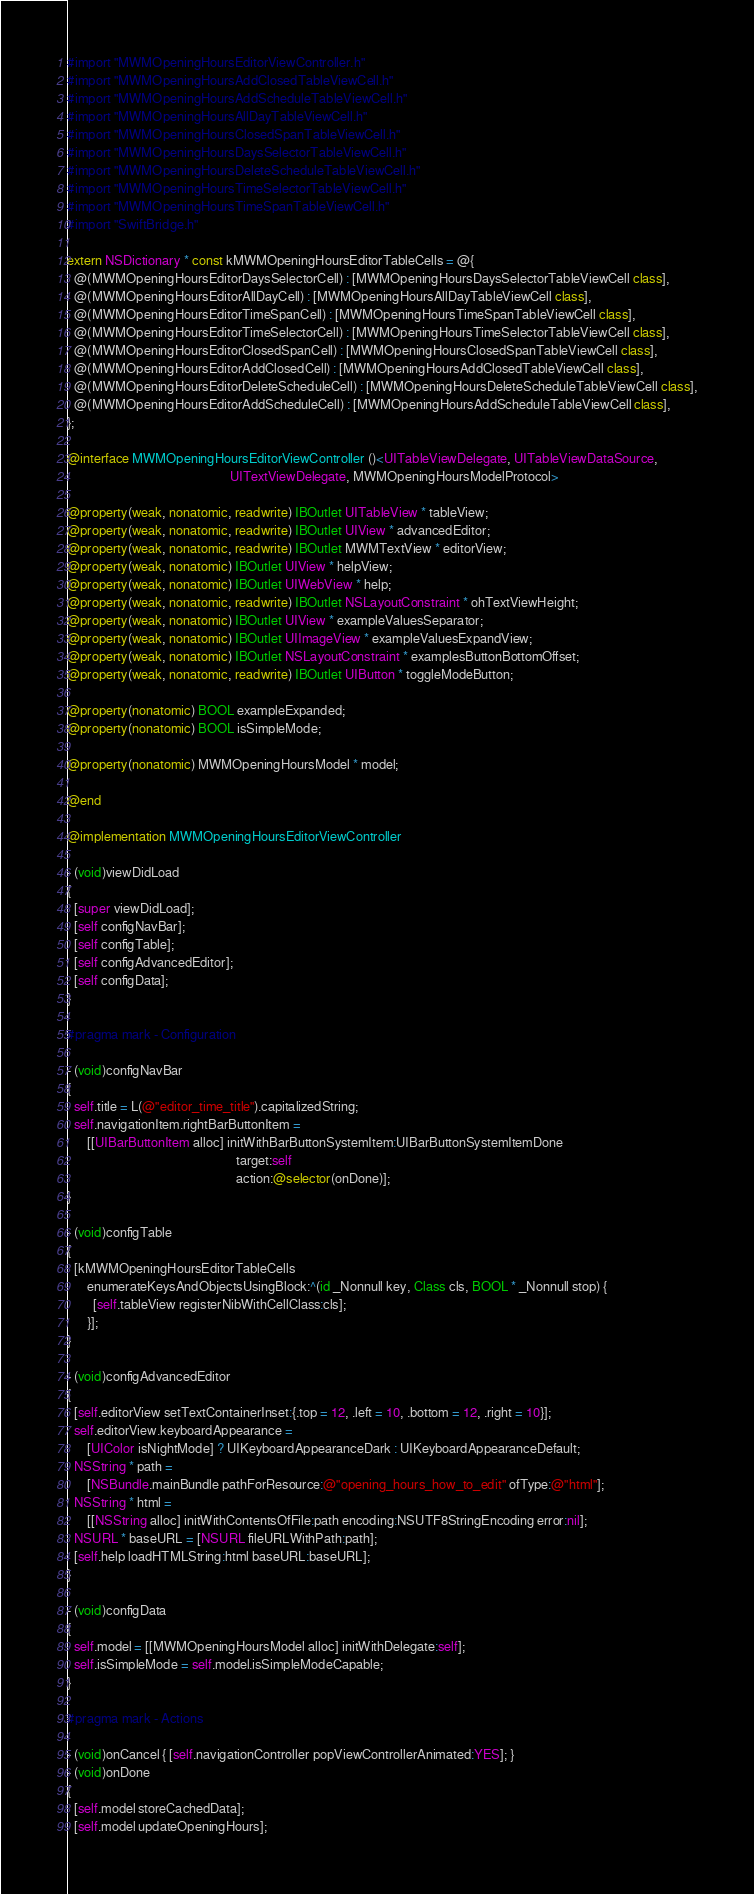Convert code to text. <code><loc_0><loc_0><loc_500><loc_500><_ObjectiveC_>#import "MWMOpeningHoursEditorViewController.h"
#import "MWMOpeningHoursAddClosedTableViewCell.h"
#import "MWMOpeningHoursAddScheduleTableViewCell.h"
#import "MWMOpeningHoursAllDayTableViewCell.h"
#import "MWMOpeningHoursClosedSpanTableViewCell.h"
#import "MWMOpeningHoursDaysSelectorTableViewCell.h"
#import "MWMOpeningHoursDeleteScheduleTableViewCell.h"
#import "MWMOpeningHoursTimeSelectorTableViewCell.h"
#import "MWMOpeningHoursTimeSpanTableViewCell.h"
#import "SwiftBridge.h"

extern NSDictionary * const kMWMOpeningHoursEditorTableCells = @{
  @(MWMOpeningHoursEditorDaysSelectorCell) : [MWMOpeningHoursDaysSelectorTableViewCell class],
  @(MWMOpeningHoursEditorAllDayCell) : [MWMOpeningHoursAllDayTableViewCell class],
  @(MWMOpeningHoursEditorTimeSpanCell) : [MWMOpeningHoursTimeSpanTableViewCell class],
  @(MWMOpeningHoursEditorTimeSelectorCell) : [MWMOpeningHoursTimeSelectorTableViewCell class],
  @(MWMOpeningHoursEditorClosedSpanCell) : [MWMOpeningHoursClosedSpanTableViewCell class],
  @(MWMOpeningHoursEditorAddClosedCell) : [MWMOpeningHoursAddClosedTableViewCell class],
  @(MWMOpeningHoursEditorDeleteScheduleCell) : [MWMOpeningHoursDeleteScheduleTableViewCell class],
  @(MWMOpeningHoursEditorAddScheduleCell) : [MWMOpeningHoursAddScheduleTableViewCell class],
};

@interface MWMOpeningHoursEditorViewController ()<UITableViewDelegate, UITableViewDataSource,
                                                  UITextViewDelegate, MWMOpeningHoursModelProtocol>

@property(weak, nonatomic, readwrite) IBOutlet UITableView * tableView;
@property(weak, nonatomic, readwrite) IBOutlet UIView * advancedEditor;
@property(weak, nonatomic, readwrite) IBOutlet MWMTextView * editorView;
@property(weak, nonatomic) IBOutlet UIView * helpView;
@property(weak, nonatomic) IBOutlet UIWebView * help;
@property(weak, nonatomic, readwrite) IBOutlet NSLayoutConstraint * ohTextViewHeight;
@property(weak, nonatomic) IBOutlet UIView * exampleValuesSeparator;
@property(weak, nonatomic) IBOutlet UIImageView * exampleValuesExpandView;
@property(weak, nonatomic) IBOutlet NSLayoutConstraint * examplesButtonBottomOffset;
@property(weak, nonatomic, readwrite) IBOutlet UIButton * toggleModeButton;

@property(nonatomic) BOOL exampleExpanded;
@property(nonatomic) BOOL isSimpleMode;

@property(nonatomic) MWMOpeningHoursModel * model;

@end

@implementation MWMOpeningHoursEditorViewController

- (void)viewDidLoad
{
  [super viewDidLoad];
  [self configNavBar];
  [self configTable];
  [self configAdvancedEditor];
  [self configData];
}

#pragma mark - Configuration

- (void)configNavBar
{
  self.title = L(@"editor_time_title").capitalizedString;
  self.navigationItem.rightBarButtonItem =
      [[UIBarButtonItem alloc] initWithBarButtonSystemItem:UIBarButtonSystemItemDone
                                                    target:self
                                                    action:@selector(onDone)];
}

- (void)configTable
{
  [kMWMOpeningHoursEditorTableCells
      enumerateKeysAndObjectsUsingBlock:^(id _Nonnull key, Class cls, BOOL * _Nonnull stop) {
        [self.tableView registerNibWithCellClass:cls];
      }];
}

- (void)configAdvancedEditor
{
  [self.editorView setTextContainerInset:{.top = 12, .left = 10, .bottom = 12, .right = 10}];
  self.editorView.keyboardAppearance =
      [UIColor isNightMode] ? UIKeyboardAppearanceDark : UIKeyboardAppearanceDefault;
  NSString * path =
      [NSBundle.mainBundle pathForResource:@"opening_hours_how_to_edit" ofType:@"html"];
  NSString * html =
      [[NSString alloc] initWithContentsOfFile:path encoding:NSUTF8StringEncoding error:nil];
  NSURL * baseURL = [NSURL fileURLWithPath:path];
  [self.help loadHTMLString:html baseURL:baseURL];
}

- (void)configData
{
  self.model = [[MWMOpeningHoursModel alloc] initWithDelegate:self];
  self.isSimpleMode = self.model.isSimpleModeCapable;
}

#pragma mark - Actions

- (void)onCancel { [self.navigationController popViewControllerAnimated:YES]; }
- (void)onDone
{
  [self.model storeCachedData];
  [self.model updateOpeningHours];</code> 